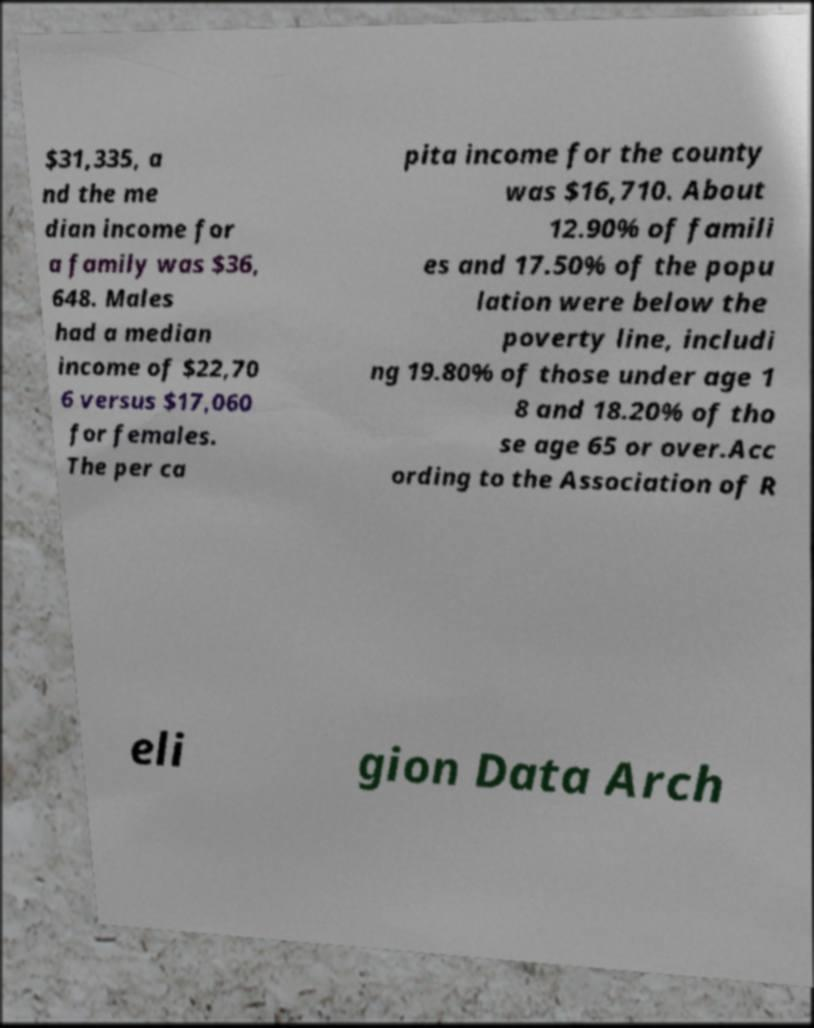Can you read and provide the text displayed in the image?This photo seems to have some interesting text. Can you extract and type it out for me? $31,335, a nd the me dian income for a family was $36, 648. Males had a median income of $22,70 6 versus $17,060 for females. The per ca pita income for the county was $16,710. About 12.90% of famili es and 17.50% of the popu lation were below the poverty line, includi ng 19.80% of those under age 1 8 and 18.20% of tho se age 65 or over.Acc ording to the Association of R eli gion Data Arch 